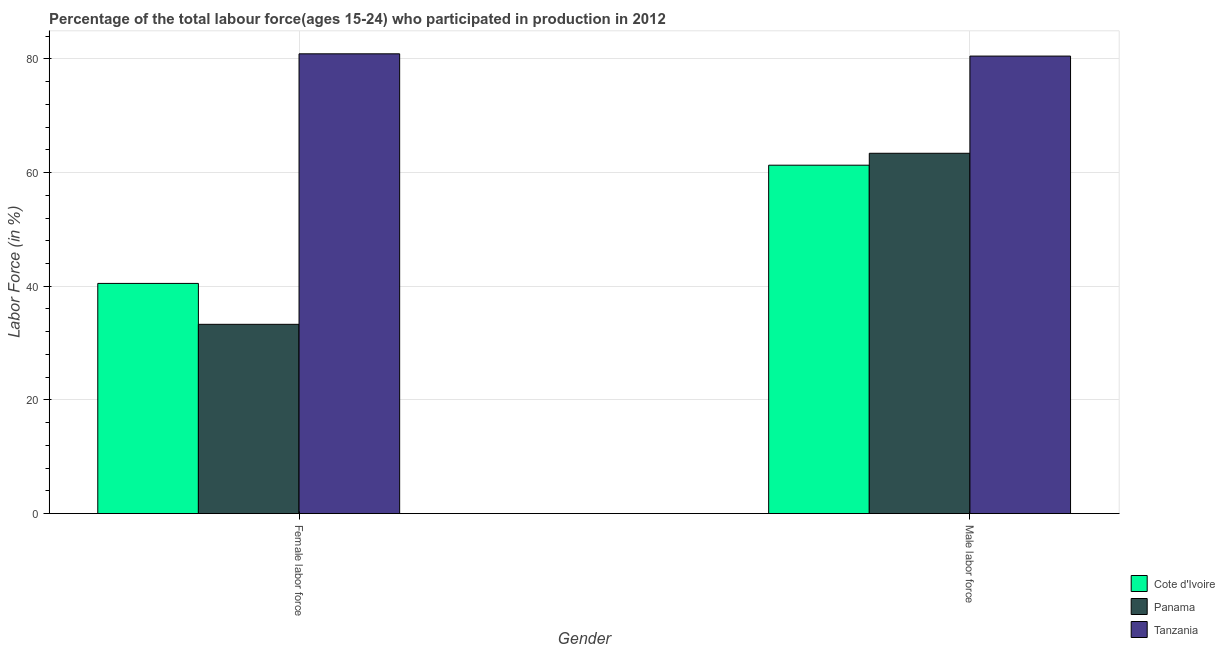How many different coloured bars are there?
Your answer should be very brief. 3. Are the number of bars on each tick of the X-axis equal?
Offer a very short reply. Yes. How many bars are there on the 2nd tick from the right?
Provide a succinct answer. 3. What is the label of the 1st group of bars from the left?
Keep it short and to the point. Female labor force. What is the percentage of female labor force in Cote d'Ivoire?
Offer a very short reply. 40.5. Across all countries, what is the maximum percentage of male labour force?
Give a very brief answer. 80.5. Across all countries, what is the minimum percentage of male labour force?
Offer a very short reply. 61.3. In which country was the percentage of female labor force maximum?
Your answer should be very brief. Tanzania. In which country was the percentage of female labor force minimum?
Give a very brief answer. Panama. What is the total percentage of male labour force in the graph?
Your answer should be very brief. 205.2. What is the difference between the percentage of female labor force in Tanzania and that in Panama?
Provide a succinct answer. 47.6. What is the difference between the percentage of male labour force in Cote d'Ivoire and the percentage of female labor force in Tanzania?
Your response must be concise. -19.6. What is the average percentage of female labor force per country?
Offer a terse response. 51.57. What is the difference between the percentage of male labour force and percentage of female labor force in Tanzania?
Offer a terse response. -0.4. What is the ratio of the percentage of male labour force in Panama to that in Cote d'Ivoire?
Your answer should be compact. 1.03. Is the percentage of male labour force in Panama less than that in Cote d'Ivoire?
Give a very brief answer. No. What does the 1st bar from the left in Male labor force represents?
Offer a terse response. Cote d'Ivoire. What does the 3rd bar from the right in Female labor force represents?
Your answer should be compact. Cote d'Ivoire. Are all the bars in the graph horizontal?
Your response must be concise. No. How many countries are there in the graph?
Your answer should be very brief. 3. Are the values on the major ticks of Y-axis written in scientific E-notation?
Your response must be concise. No. Does the graph contain any zero values?
Provide a short and direct response. No. Does the graph contain grids?
Ensure brevity in your answer.  Yes. How many legend labels are there?
Provide a short and direct response. 3. How are the legend labels stacked?
Offer a terse response. Vertical. What is the title of the graph?
Keep it short and to the point. Percentage of the total labour force(ages 15-24) who participated in production in 2012. What is the label or title of the Y-axis?
Offer a terse response. Labor Force (in %). What is the Labor Force (in %) in Cote d'Ivoire in Female labor force?
Keep it short and to the point. 40.5. What is the Labor Force (in %) in Panama in Female labor force?
Keep it short and to the point. 33.3. What is the Labor Force (in %) in Tanzania in Female labor force?
Provide a succinct answer. 80.9. What is the Labor Force (in %) of Cote d'Ivoire in Male labor force?
Give a very brief answer. 61.3. What is the Labor Force (in %) of Panama in Male labor force?
Provide a short and direct response. 63.4. What is the Labor Force (in %) in Tanzania in Male labor force?
Offer a very short reply. 80.5. Across all Gender, what is the maximum Labor Force (in %) of Cote d'Ivoire?
Your answer should be very brief. 61.3. Across all Gender, what is the maximum Labor Force (in %) of Panama?
Make the answer very short. 63.4. Across all Gender, what is the maximum Labor Force (in %) of Tanzania?
Keep it short and to the point. 80.9. Across all Gender, what is the minimum Labor Force (in %) of Cote d'Ivoire?
Your answer should be compact. 40.5. Across all Gender, what is the minimum Labor Force (in %) in Panama?
Your answer should be compact. 33.3. Across all Gender, what is the minimum Labor Force (in %) of Tanzania?
Offer a very short reply. 80.5. What is the total Labor Force (in %) in Cote d'Ivoire in the graph?
Your answer should be very brief. 101.8. What is the total Labor Force (in %) in Panama in the graph?
Give a very brief answer. 96.7. What is the total Labor Force (in %) of Tanzania in the graph?
Your answer should be compact. 161.4. What is the difference between the Labor Force (in %) in Cote d'Ivoire in Female labor force and that in Male labor force?
Give a very brief answer. -20.8. What is the difference between the Labor Force (in %) of Panama in Female labor force and that in Male labor force?
Provide a short and direct response. -30.1. What is the difference between the Labor Force (in %) in Tanzania in Female labor force and that in Male labor force?
Keep it short and to the point. 0.4. What is the difference between the Labor Force (in %) of Cote d'Ivoire in Female labor force and the Labor Force (in %) of Panama in Male labor force?
Your answer should be compact. -22.9. What is the difference between the Labor Force (in %) of Panama in Female labor force and the Labor Force (in %) of Tanzania in Male labor force?
Your answer should be very brief. -47.2. What is the average Labor Force (in %) in Cote d'Ivoire per Gender?
Make the answer very short. 50.9. What is the average Labor Force (in %) of Panama per Gender?
Provide a succinct answer. 48.35. What is the average Labor Force (in %) in Tanzania per Gender?
Your response must be concise. 80.7. What is the difference between the Labor Force (in %) in Cote d'Ivoire and Labor Force (in %) in Panama in Female labor force?
Ensure brevity in your answer.  7.2. What is the difference between the Labor Force (in %) in Cote d'Ivoire and Labor Force (in %) in Tanzania in Female labor force?
Provide a succinct answer. -40.4. What is the difference between the Labor Force (in %) in Panama and Labor Force (in %) in Tanzania in Female labor force?
Provide a short and direct response. -47.6. What is the difference between the Labor Force (in %) of Cote d'Ivoire and Labor Force (in %) of Tanzania in Male labor force?
Offer a terse response. -19.2. What is the difference between the Labor Force (in %) in Panama and Labor Force (in %) in Tanzania in Male labor force?
Ensure brevity in your answer.  -17.1. What is the ratio of the Labor Force (in %) of Cote d'Ivoire in Female labor force to that in Male labor force?
Ensure brevity in your answer.  0.66. What is the ratio of the Labor Force (in %) of Panama in Female labor force to that in Male labor force?
Make the answer very short. 0.53. What is the difference between the highest and the second highest Labor Force (in %) of Cote d'Ivoire?
Offer a terse response. 20.8. What is the difference between the highest and the second highest Labor Force (in %) in Panama?
Give a very brief answer. 30.1. What is the difference between the highest and the second highest Labor Force (in %) in Tanzania?
Offer a terse response. 0.4. What is the difference between the highest and the lowest Labor Force (in %) of Cote d'Ivoire?
Your answer should be very brief. 20.8. What is the difference between the highest and the lowest Labor Force (in %) of Panama?
Your answer should be very brief. 30.1. What is the difference between the highest and the lowest Labor Force (in %) of Tanzania?
Your response must be concise. 0.4. 